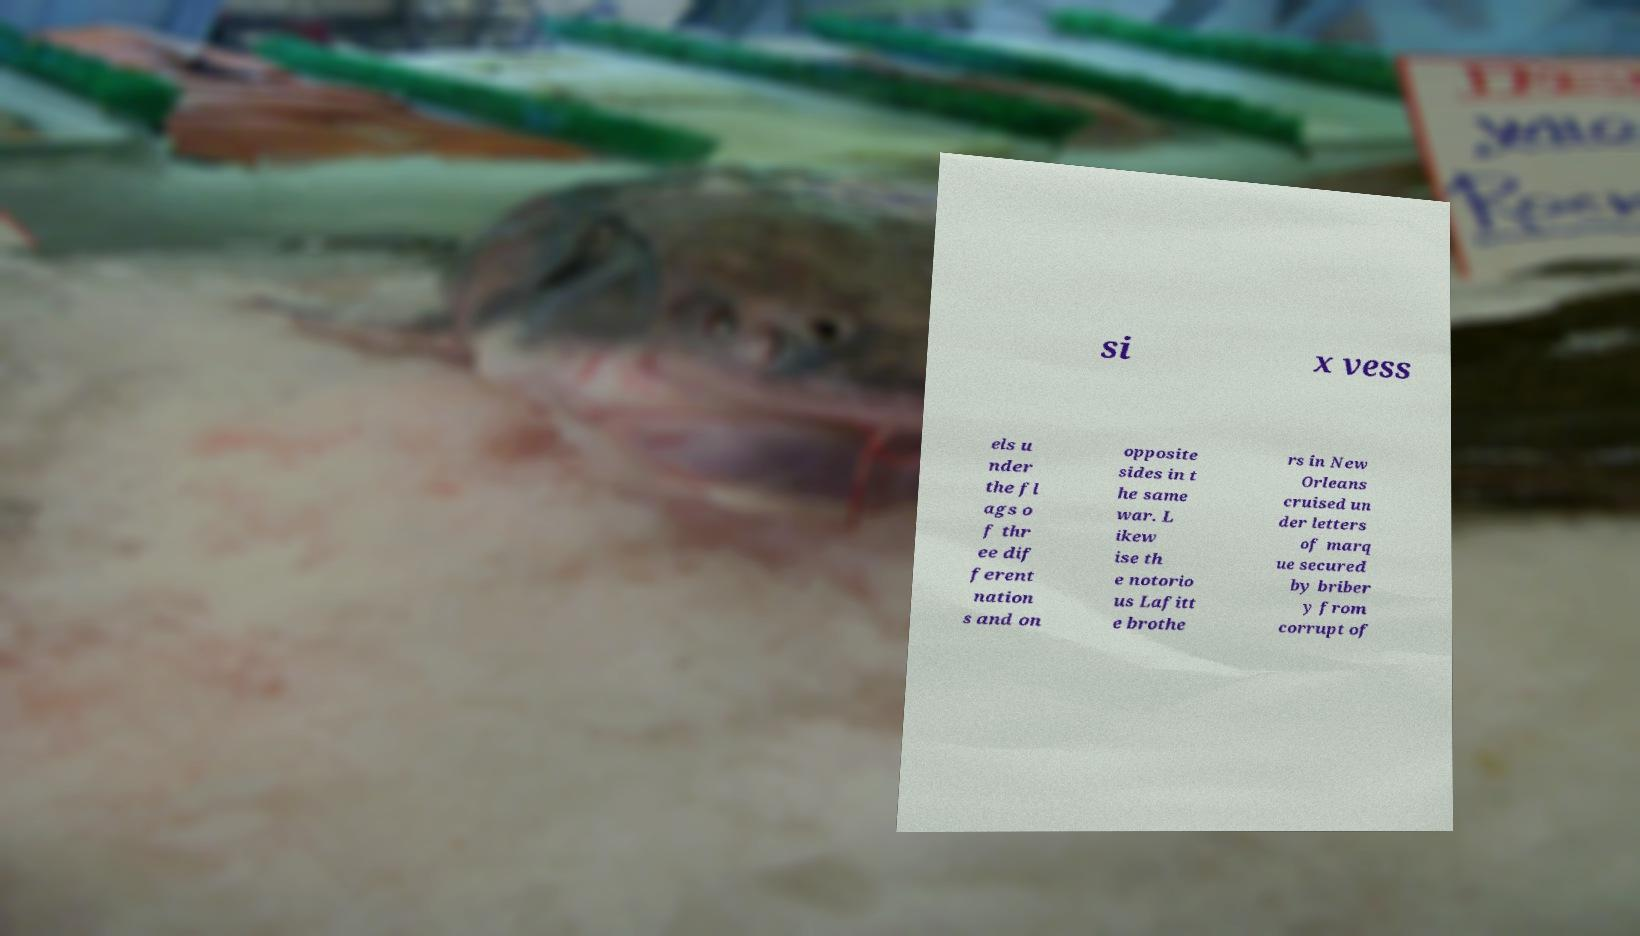For documentation purposes, I need the text within this image transcribed. Could you provide that? si x vess els u nder the fl ags o f thr ee dif ferent nation s and on opposite sides in t he same war. L ikew ise th e notorio us Lafitt e brothe rs in New Orleans cruised un der letters of marq ue secured by briber y from corrupt of 